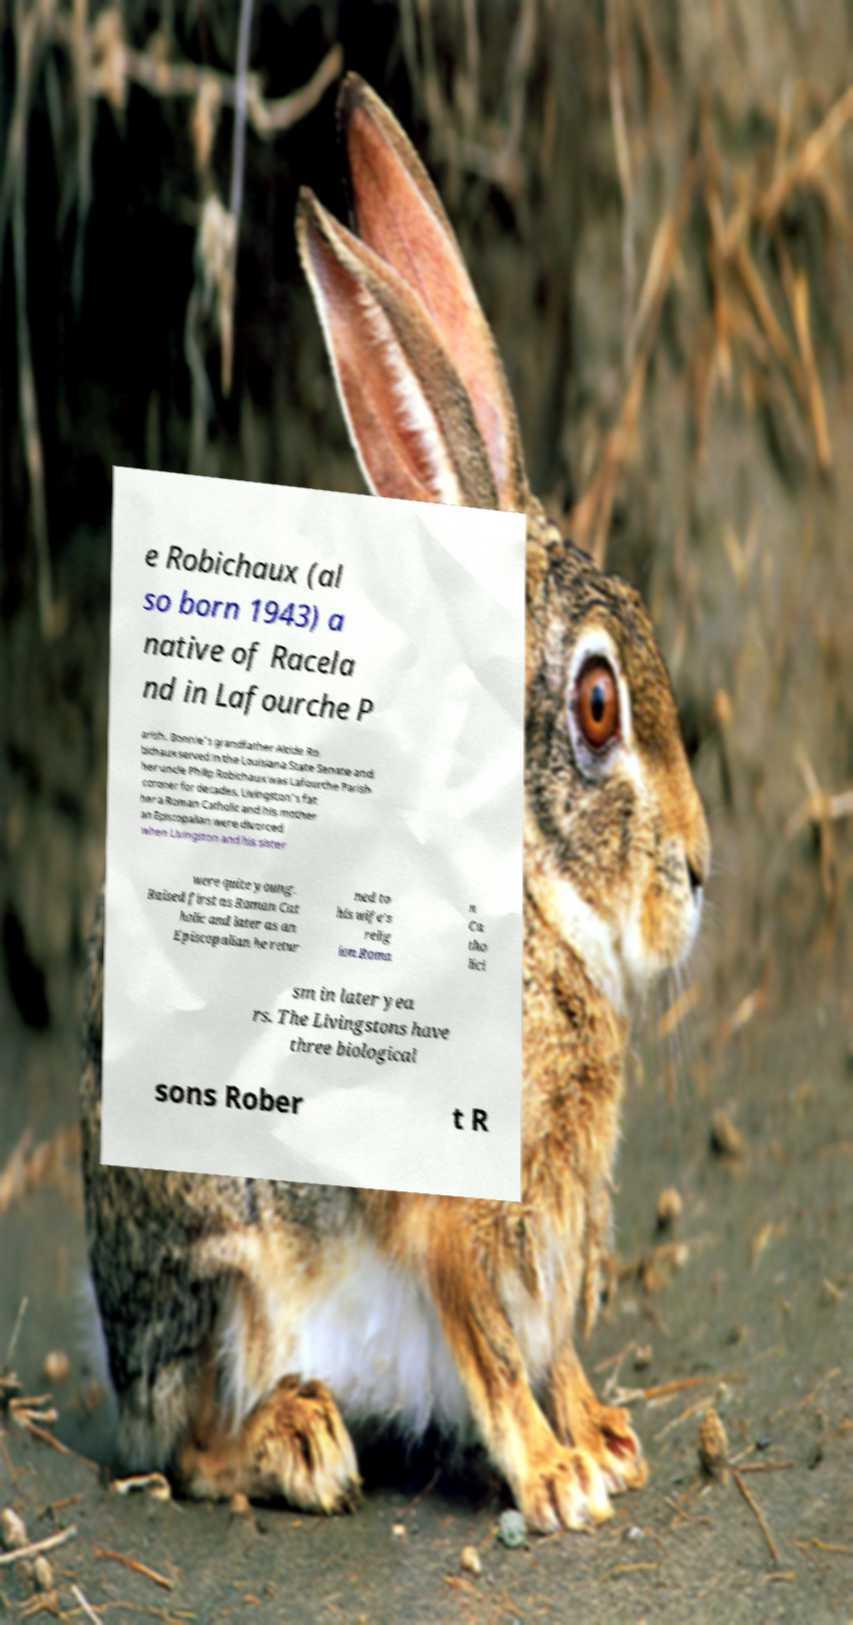There's text embedded in this image that I need extracted. Can you transcribe it verbatim? e Robichaux (al so born 1943) a native of Racela nd in Lafourche P arish. Bonnie's grandfather Alcide Ro bichaux served in the Louisiana State Senate and her uncle Philip Robichaux was Lafourche Parish coroner for decades. Livingston's fat her a Roman Catholic and his mother an Episcopalian were divorced when Livingston and his sister were quite young. Raised first as Roman Cat holic and later as an Episcopalian he retur ned to his wife's relig ion Roma n Ca tho lici sm in later yea rs. The Livingstons have three biological sons Rober t R 